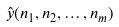Convert formula to latex. <formula><loc_0><loc_0><loc_500><loc_500>\hat { y } ( n _ { 1 } , n _ { 2 } , \dots , n _ { m } )</formula> 